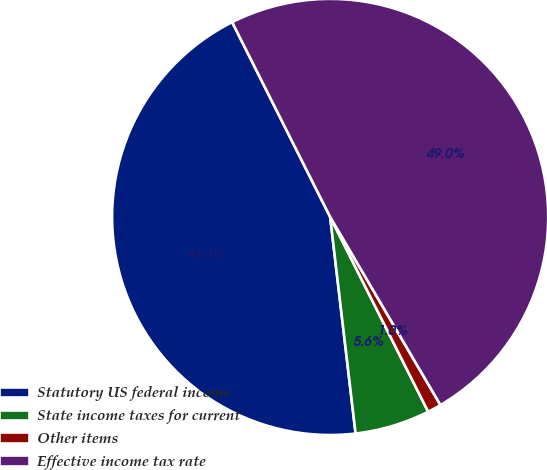<chart> <loc_0><loc_0><loc_500><loc_500><pie_chart><fcel>Statutory US federal income<fcel>State income taxes for current<fcel>Other items<fcel>Effective income tax rate<nl><fcel>44.44%<fcel>5.56%<fcel>1.02%<fcel>48.98%<nl></chart> 